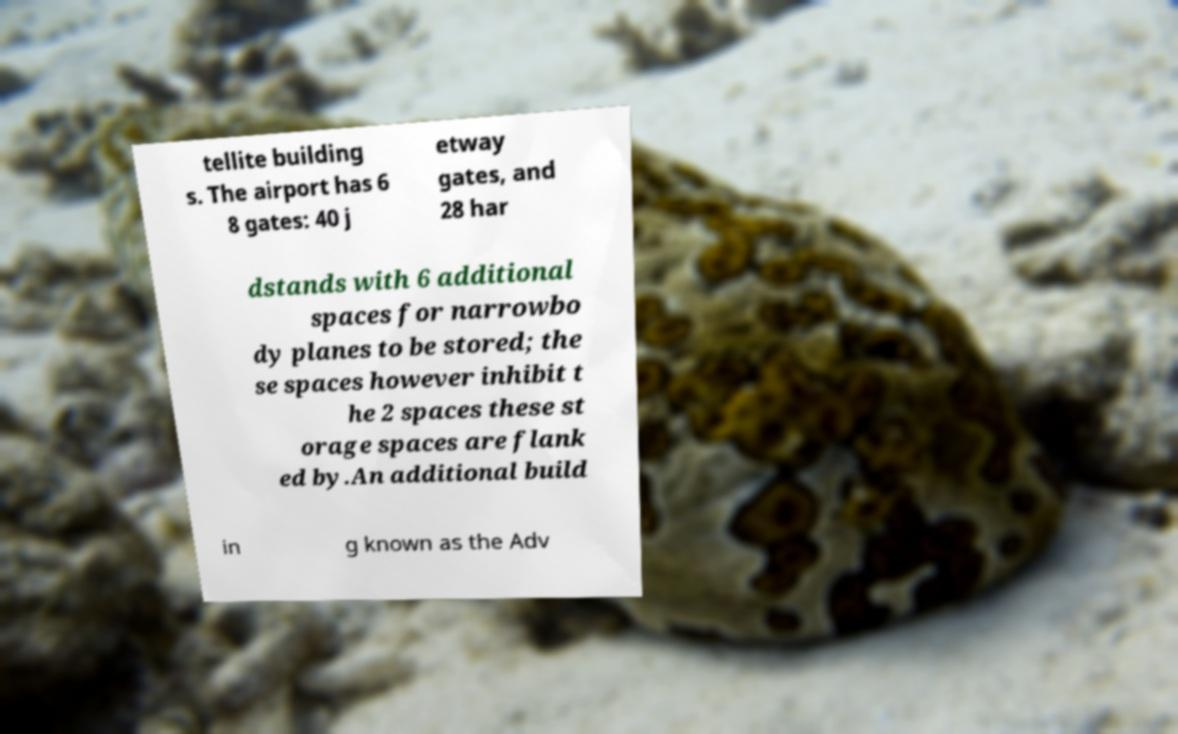Could you assist in decoding the text presented in this image and type it out clearly? tellite building s. The airport has 6 8 gates: 40 j etway gates, and 28 har dstands with 6 additional spaces for narrowbo dy planes to be stored; the se spaces however inhibit t he 2 spaces these st orage spaces are flank ed by.An additional build in g known as the Adv 